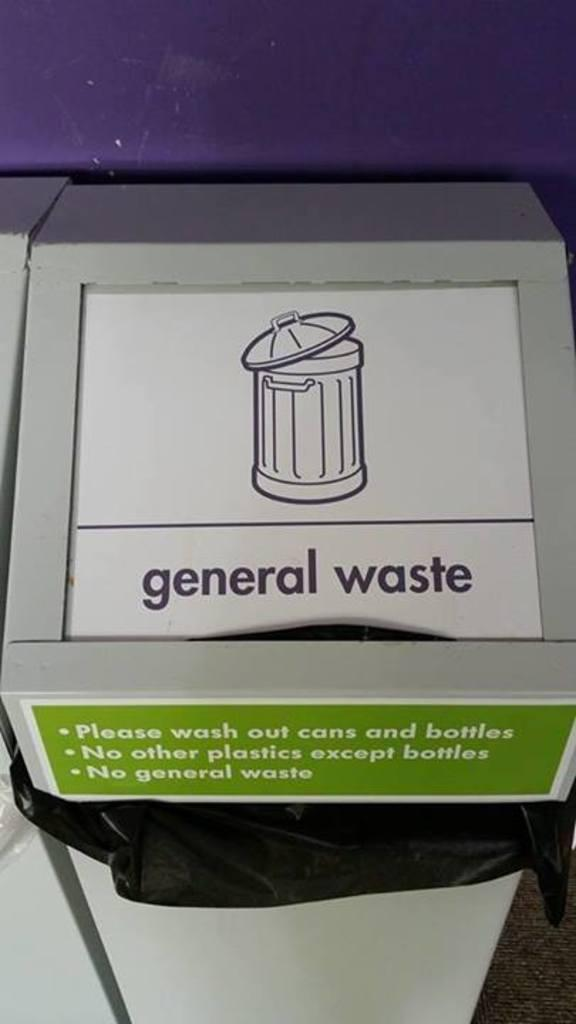Provide a one-sentence caption for the provided image. A trash can that says general waste on it sits against a purple wall. 